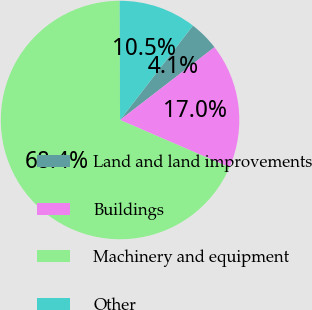<chart> <loc_0><loc_0><loc_500><loc_500><pie_chart><fcel>Land and land improvements<fcel>Buildings<fcel>Machinery and equipment<fcel>Other<nl><fcel>4.08%<fcel>16.95%<fcel>68.45%<fcel>10.52%<nl></chart> 